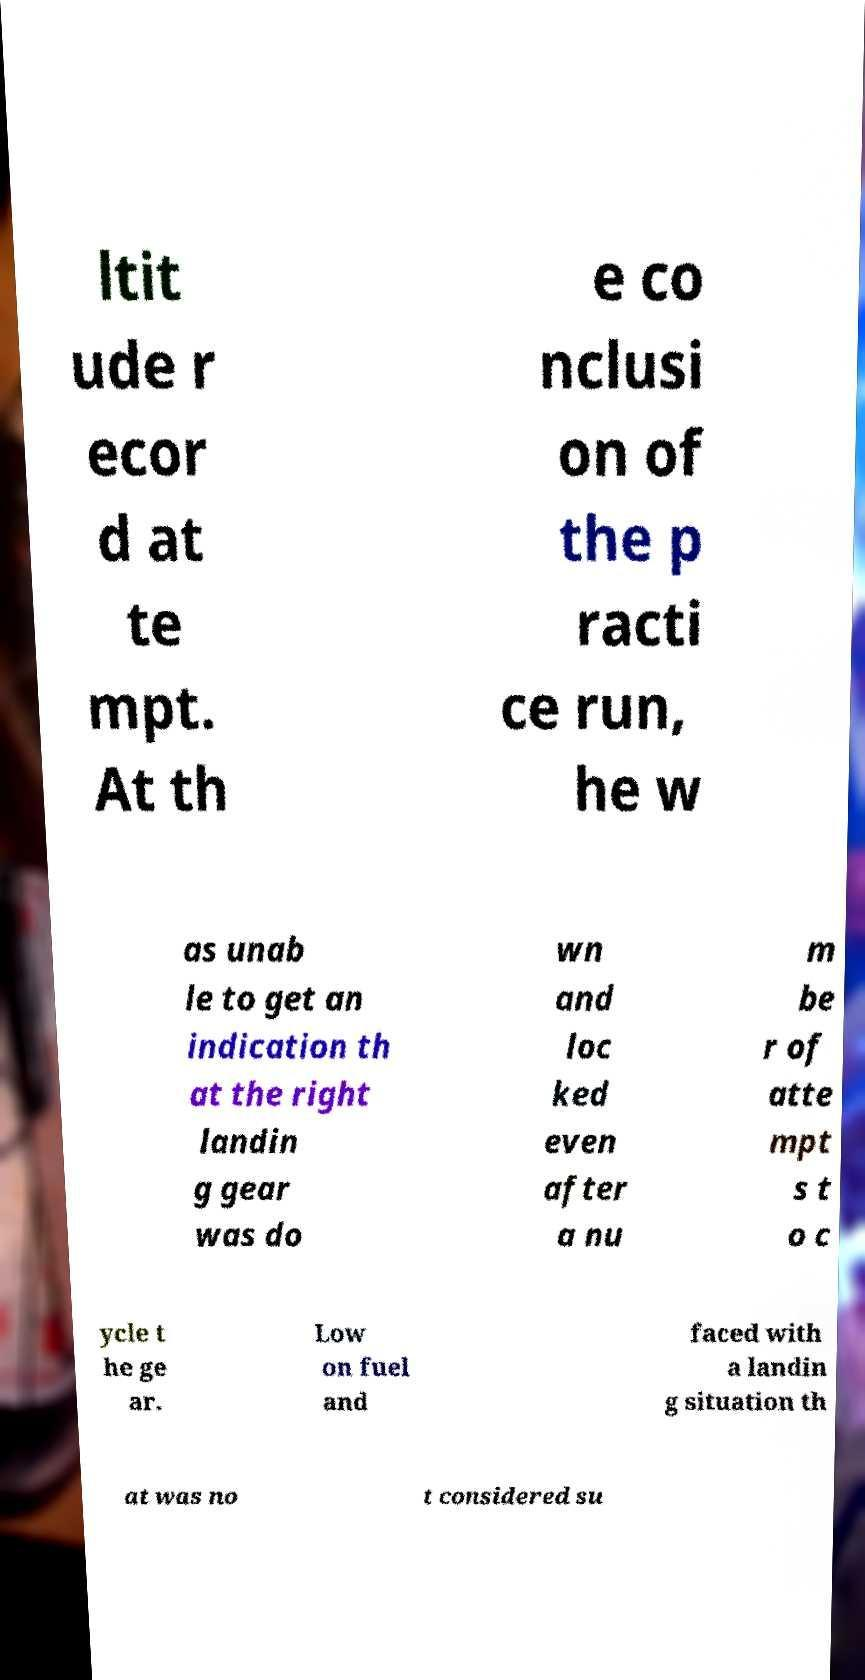Could you extract and type out the text from this image? ltit ude r ecor d at te mpt. At th e co nclusi on of the p racti ce run, he w as unab le to get an indication th at the right landin g gear was do wn and loc ked even after a nu m be r of atte mpt s t o c ycle t he ge ar. Low on fuel and faced with a landin g situation th at was no t considered su 